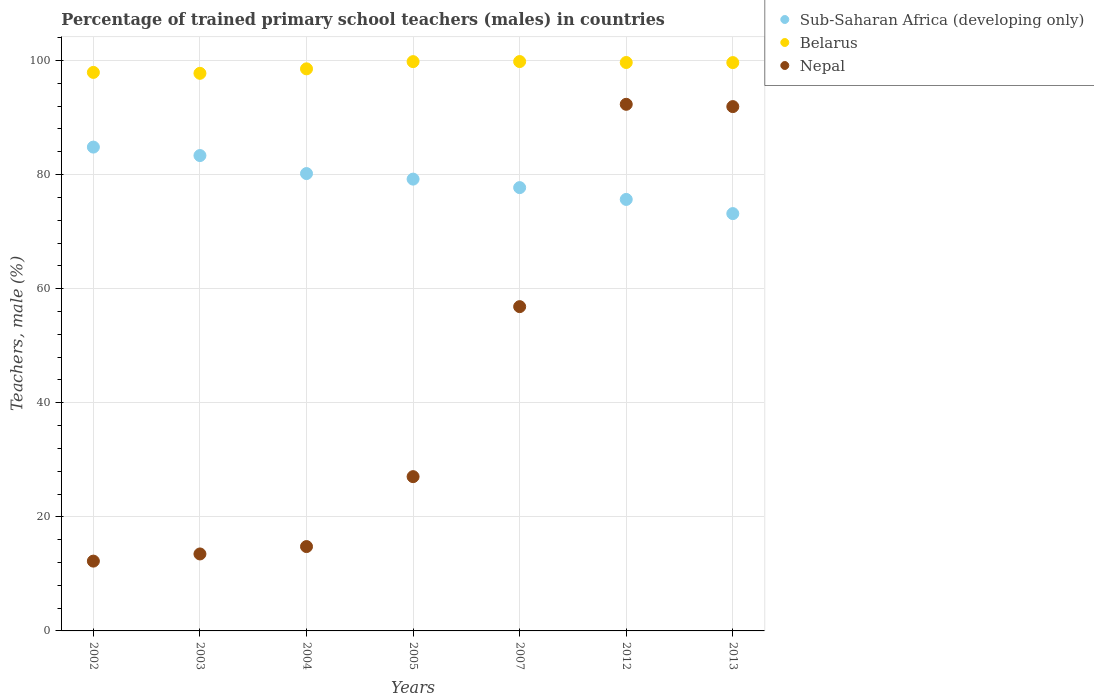What is the percentage of trained primary school teachers (males) in Sub-Saharan Africa (developing only) in 2013?
Make the answer very short. 73.15. Across all years, what is the maximum percentage of trained primary school teachers (males) in Nepal?
Keep it short and to the point. 92.31. Across all years, what is the minimum percentage of trained primary school teachers (males) in Sub-Saharan Africa (developing only)?
Offer a very short reply. 73.15. What is the total percentage of trained primary school teachers (males) in Nepal in the graph?
Provide a succinct answer. 308.63. What is the difference between the percentage of trained primary school teachers (males) in Belarus in 2003 and that in 2007?
Keep it short and to the point. -2.06. What is the difference between the percentage of trained primary school teachers (males) in Belarus in 2005 and the percentage of trained primary school teachers (males) in Sub-Saharan Africa (developing only) in 2007?
Provide a succinct answer. 22.08. What is the average percentage of trained primary school teachers (males) in Nepal per year?
Your answer should be very brief. 44.09. In the year 2002, what is the difference between the percentage of trained primary school teachers (males) in Sub-Saharan Africa (developing only) and percentage of trained primary school teachers (males) in Nepal?
Keep it short and to the point. 72.58. What is the ratio of the percentage of trained primary school teachers (males) in Belarus in 2002 to that in 2003?
Provide a succinct answer. 1. Is the percentage of trained primary school teachers (males) in Sub-Saharan Africa (developing only) in 2002 less than that in 2013?
Give a very brief answer. No. Is the difference between the percentage of trained primary school teachers (males) in Sub-Saharan Africa (developing only) in 2007 and 2013 greater than the difference between the percentage of trained primary school teachers (males) in Nepal in 2007 and 2013?
Keep it short and to the point. Yes. What is the difference between the highest and the second highest percentage of trained primary school teachers (males) in Nepal?
Your answer should be compact. 0.4. What is the difference between the highest and the lowest percentage of trained primary school teachers (males) in Nepal?
Offer a terse response. 80.08. In how many years, is the percentage of trained primary school teachers (males) in Belarus greater than the average percentage of trained primary school teachers (males) in Belarus taken over all years?
Ensure brevity in your answer.  4. Is the sum of the percentage of trained primary school teachers (males) in Sub-Saharan Africa (developing only) in 2004 and 2012 greater than the maximum percentage of trained primary school teachers (males) in Nepal across all years?
Offer a very short reply. Yes. Is it the case that in every year, the sum of the percentage of trained primary school teachers (males) in Nepal and percentage of trained primary school teachers (males) in Belarus  is greater than the percentage of trained primary school teachers (males) in Sub-Saharan Africa (developing only)?
Offer a very short reply. Yes. Is the percentage of trained primary school teachers (males) in Belarus strictly greater than the percentage of trained primary school teachers (males) in Nepal over the years?
Give a very brief answer. Yes. Is the percentage of trained primary school teachers (males) in Belarus strictly less than the percentage of trained primary school teachers (males) in Nepal over the years?
Your response must be concise. No. How many dotlines are there?
Ensure brevity in your answer.  3. How many years are there in the graph?
Provide a succinct answer. 7. Does the graph contain any zero values?
Provide a succinct answer. No. Does the graph contain grids?
Offer a very short reply. Yes. Where does the legend appear in the graph?
Give a very brief answer. Top right. What is the title of the graph?
Ensure brevity in your answer.  Percentage of trained primary school teachers (males) in countries. Does "Caribbean small states" appear as one of the legend labels in the graph?
Your answer should be very brief. No. What is the label or title of the X-axis?
Provide a succinct answer. Years. What is the label or title of the Y-axis?
Make the answer very short. Teachers, male (%). What is the Teachers, male (%) of Sub-Saharan Africa (developing only) in 2002?
Make the answer very short. 84.81. What is the Teachers, male (%) of Belarus in 2002?
Provide a succinct answer. 97.91. What is the Teachers, male (%) in Nepal in 2002?
Offer a very short reply. 12.24. What is the Teachers, male (%) in Sub-Saharan Africa (developing only) in 2003?
Ensure brevity in your answer.  83.33. What is the Teachers, male (%) of Belarus in 2003?
Offer a very short reply. 97.74. What is the Teachers, male (%) of Nepal in 2003?
Keep it short and to the point. 13.49. What is the Teachers, male (%) in Sub-Saharan Africa (developing only) in 2004?
Offer a very short reply. 80.17. What is the Teachers, male (%) in Belarus in 2004?
Provide a succinct answer. 98.53. What is the Teachers, male (%) of Nepal in 2004?
Offer a very short reply. 14.79. What is the Teachers, male (%) in Sub-Saharan Africa (developing only) in 2005?
Offer a very short reply. 79.2. What is the Teachers, male (%) of Belarus in 2005?
Your response must be concise. 99.8. What is the Teachers, male (%) of Nepal in 2005?
Ensure brevity in your answer.  27.04. What is the Teachers, male (%) in Sub-Saharan Africa (developing only) in 2007?
Offer a terse response. 77.71. What is the Teachers, male (%) in Belarus in 2007?
Provide a short and direct response. 99.81. What is the Teachers, male (%) of Nepal in 2007?
Your answer should be compact. 56.85. What is the Teachers, male (%) of Sub-Saharan Africa (developing only) in 2012?
Offer a very short reply. 75.64. What is the Teachers, male (%) in Belarus in 2012?
Give a very brief answer. 99.64. What is the Teachers, male (%) of Nepal in 2012?
Offer a very short reply. 92.31. What is the Teachers, male (%) in Sub-Saharan Africa (developing only) in 2013?
Provide a succinct answer. 73.15. What is the Teachers, male (%) of Belarus in 2013?
Provide a succinct answer. 99.63. What is the Teachers, male (%) in Nepal in 2013?
Make the answer very short. 91.91. Across all years, what is the maximum Teachers, male (%) in Sub-Saharan Africa (developing only)?
Ensure brevity in your answer.  84.81. Across all years, what is the maximum Teachers, male (%) of Belarus?
Your answer should be compact. 99.81. Across all years, what is the maximum Teachers, male (%) in Nepal?
Provide a succinct answer. 92.31. Across all years, what is the minimum Teachers, male (%) of Sub-Saharan Africa (developing only)?
Make the answer very short. 73.15. Across all years, what is the minimum Teachers, male (%) of Belarus?
Provide a short and direct response. 97.74. Across all years, what is the minimum Teachers, male (%) in Nepal?
Keep it short and to the point. 12.24. What is the total Teachers, male (%) of Sub-Saharan Africa (developing only) in the graph?
Make the answer very short. 554.02. What is the total Teachers, male (%) of Belarus in the graph?
Provide a short and direct response. 693.05. What is the total Teachers, male (%) of Nepal in the graph?
Your answer should be compact. 308.63. What is the difference between the Teachers, male (%) of Sub-Saharan Africa (developing only) in 2002 and that in 2003?
Make the answer very short. 1.48. What is the difference between the Teachers, male (%) of Belarus in 2002 and that in 2003?
Your answer should be very brief. 0.16. What is the difference between the Teachers, male (%) in Nepal in 2002 and that in 2003?
Offer a terse response. -1.26. What is the difference between the Teachers, male (%) in Sub-Saharan Africa (developing only) in 2002 and that in 2004?
Provide a short and direct response. 4.64. What is the difference between the Teachers, male (%) in Belarus in 2002 and that in 2004?
Provide a succinct answer. -0.62. What is the difference between the Teachers, male (%) in Nepal in 2002 and that in 2004?
Ensure brevity in your answer.  -2.55. What is the difference between the Teachers, male (%) in Sub-Saharan Africa (developing only) in 2002 and that in 2005?
Your answer should be compact. 5.61. What is the difference between the Teachers, male (%) of Belarus in 2002 and that in 2005?
Make the answer very short. -1.89. What is the difference between the Teachers, male (%) of Nepal in 2002 and that in 2005?
Provide a short and direct response. -14.81. What is the difference between the Teachers, male (%) of Sub-Saharan Africa (developing only) in 2002 and that in 2007?
Give a very brief answer. 7.1. What is the difference between the Teachers, male (%) in Belarus in 2002 and that in 2007?
Keep it short and to the point. -1.9. What is the difference between the Teachers, male (%) of Nepal in 2002 and that in 2007?
Your response must be concise. -44.61. What is the difference between the Teachers, male (%) of Sub-Saharan Africa (developing only) in 2002 and that in 2012?
Offer a terse response. 9.17. What is the difference between the Teachers, male (%) of Belarus in 2002 and that in 2012?
Ensure brevity in your answer.  -1.74. What is the difference between the Teachers, male (%) of Nepal in 2002 and that in 2012?
Your response must be concise. -80.08. What is the difference between the Teachers, male (%) of Sub-Saharan Africa (developing only) in 2002 and that in 2013?
Your answer should be compact. 11.66. What is the difference between the Teachers, male (%) in Belarus in 2002 and that in 2013?
Provide a succinct answer. -1.72. What is the difference between the Teachers, male (%) of Nepal in 2002 and that in 2013?
Your response must be concise. -79.68. What is the difference between the Teachers, male (%) of Sub-Saharan Africa (developing only) in 2003 and that in 2004?
Give a very brief answer. 3.16. What is the difference between the Teachers, male (%) of Belarus in 2003 and that in 2004?
Offer a very short reply. -0.79. What is the difference between the Teachers, male (%) of Nepal in 2003 and that in 2004?
Ensure brevity in your answer.  -1.29. What is the difference between the Teachers, male (%) in Sub-Saharan Africa (developing only) in 2003 and that in 2005?
Give a very brief answer. 4.13. What is the difference between the Teachers, male (%) in Belarus in 2003 and that in 2005?
Your answer should be very brief. -2.05. What is the difference between the Teachers, male (%) of Nepal in 2003 and that in 2005?
Offer a very short reply. -13.55. What is the difference between the Teachers, male (%) of Sub-Saharan Africa (developing only) in 2003 and that in 2007?
Offer a terse response. 5.62. What is the difference between the Teachers, male (%) of Belarus in 2003 and that in 2007?
Provide a short and direct response. -2.06. What is the difference between the Teachers, male (%) in Nepal in 2003 and that in 2007?
Your answer should be compact. -43.35. What is the difference between the Teachers, male (%) of Sub-Saharan Africa (developing only) in 2003 and that in 2012?
Offer a very short reply. 7.69. What is the difference between the Teachers, male (%) in Belarus in 2003 and that in 2012?
Offer a terse response. -1.9. What is the difference between the Teachers, male (%) in Nepal in 2003 and that in 2012?
Make the answer very short. -78.82. What is the difference between the Teachers, male (%) in Sub-Saharan Africa (developing only) in 2003 and that in 2013?
Offer a very short reply. 10.18. What is the difference between the Teachers, male (%) in Belarus in 2003 and that in 2013?
Give a very brief answer. -1.88. What is the difference between the Teachers, male (%) of Nepal in 2003 and that in 2013?
Your answer should be very brief. -78.42. What is the difference between the Teachers, male (%) in Sub-Saharan Africa (developing only) in 2004 and that in 2005?
Give a very brief answer. 0.97. What is the difference between the Teachers, male (%) of Belarus in 2004 and that in 2005?
Ensure brevity in your answer.  -1.26. What is the difference between the Teachers, male (%) of Nepal in 2004 and that in 2005?
Give a very brief answer. -12.26. What is the difference between the Teachers, male (%) of Sub-Saharan Africa (developing only) in 2004 and that in 2007?
Your answer should be very brief. 2.46. What is the difference between the Teachers, male (%) of Belarus in 2004 and that in 2007?
Offer a terse response. -1.28. What is the difference between the Teachers, male (%) of Nepal in 2004 and that in 2007?
Provide a short and direct response. -42.06. What is the difference between the Teachers, male (%) in Sub-Saharan Africa (developing only) in 2004 and that in 2012?
Provide a short and direct response. 4.53. What is the difference between the Teachers, male (%) of Belarus in 2004 and that in 2012?
Offer a very short reply. -1.11. What is the difference between the Teachers, male (%) in Nepal in 2004 and that in 2012?
Your answer should be compact. -77.53. What is the difference between the Teachers, male (%) in Sub-Saharan Africa (developing only) in 2004 and that in 2013?
Offer a very short reply. 7.02. What is the difference between the Teachers, male (%) in Belarus in 2004 and that in 2013?
Your answer should be very brief. -1.1. What is the difference between the Teachers, male (%) of Nepal in 2004 and that in 2013?
Provide a short and direct response. -77.13. What is the difference between the Teachers, male (%) in Sub-Saharan Africa (developing only) in 2005 and that in 2007?
Provide a succinct answer. 1.49. What is the difference between the Teachers, male (%) of Belarus in 2005 and that in 2007?
Give a very brief answer. -0.01. What is the difference between the Teachers, male (%) in Nepal in 2005 and that in 2007?
Ensure brevity in your answer.  -29.8. What is the difference between the Teachers, male (%) in Sub-Saharan Africa (developing only) in 2005 and that in 2012?
Your answer should be very brief. 3.56. What is the difference between the Teachers, male (%) in Belarus in 2005 and that in 2012?
Offer a terse response. 0.15. What is the difference between the Teachers, male (%) of Nepal in 2005 and that in 2012?
Give a very brief answer. -65.27. What is the difference between the Teachers, male (%) of Sub-Saharan Africa (developing only) in 2005 and that in 2013?
Provide a short and direct response. 6.05. What is the difference between the Teachers, male (%) of Belarus in 2005 and that in 2013?
Keep it short and to the point. 0.17. What is the difference between the Teachers, male (%) in Nepal in 2005 and that in 2013?
Your answer should be very brief. -64.87. What is the difference between the Teachers, male (%) of Sub-Saharan Africa (developing only) in 2007 and that in 2012?
Provide a short and direct response. 2.07. What is the difference between the Teachers, male (%) in Belarus in 2007 and that in 2012?
Make the answer very short. 0.17. What is the difference between the Teachers, male (%) of Nepal in 2007 and that in 2012?
Ensure brevity in your answer.  -35.47. What is the difference between the Teachers, male (%) in Sub-Saharan Africa (developing only) in 2007 and that in 2013?
Your answer should be very brief. 4.56. What is the difference between the Teachers, male (%) of Belarus in 2007 and that in 2013?
Offer a terse response. 0.18. What is the difference between the Teachers, male (%) in Nepal in 2007 and that in 2013?
Give a very brief answer. -35.07. What is the difference between the Teachers, male (%) in Sub-Saharan Africa (developing only) in 2012 and that in 2013?
Provide a succinct answer. 2.49. What is the difference between the Teachers, male (%) of Belarus in 2012 and that in 2013?
Your answer should be compact. 0.02. What is the difference between the Teachers, male (%) in Nepal in 2012 and that in 2013?
Ensure brevity in your answer.  0.4. What is the difference between the Teachers, male (%) in Sub-Saharan Africa (developing only) in 2002 and the Teachers, male (%) in Belarus in 2003?
Offer a very short reply. -12.93. What is the difference between the Teachers, male (%) of Sub-Saharan Africa (developing only) in 2002 and the Teachers, male (%) of Nepal in 2003?
Offer a terse response. 71.32. What is the difference between the Teachers, male (%) in Belarus in 2002 and the Teachers, male (%) in Nepal in 2003?
Offer a very short reply. 84.41. What is the difference between the Teachers, male (%) of Sub-Saharan Africa (developing only) in 2002 and the Teachers, male (%) of Belarus in 2004?
Keep it short and to the point. -13.72. What is the difference between the Teachers, male (%) of Sub-Saharan Africa (developing only) in 2002 and the Teachers, male (%) of Nepal in 2004?
Your answer should be compact. 70.03. What is the difference between the Teachers, male (%) in Belarus in 2002 and the Teachers, male (%) in Nepal in 2004?
Ensure brevity in your answer.  83.12. What is the difference between the Teachers, male (%) in Sub-Saharan Africa (developing only) in 2002 and the Teachers, male (%) in Belarus in 2005?
Provide a short and direct response. -14.98. What is the difference between the Teachers, male (%) in Sub-Saharan Africa (developing only) in 2002 and the Teachers, male (%) in Nepal in 2005?
Your answer should be compact. 57.77. What is the difference between the Teachers, male (%) in Belarus in 2002 and the Teachers, male (%) in Nepal in 2005?
Give a very brief answer. 70.86. What is the difference between the Teachers, male (%) in Sub-Saharan Africa (developing only) in 2002 and the Teachers, male (%) in Belarus in 2007?
Your response must be concise. -15. What is the difference between the Teachers, male (%) in Sub-Saharan Africa (developing only) in 2002 and the Teachers, male (%) in Nepal in 2007?
Provide a succinct answer. 27.97. What is the difference between the Teachers, male (%) of Belarus in 2002 and the Teachers, male (%) of Nepal in 2007?
Keep it short and to the point. 41.06. What is the difference between the Teachers, male (%) of Sub-Saharan Africa (developing only) in 2002 and the Teachers, male (%) of Belarus in 2012?
Ensure brevity in your answer.  -14.83. What is the difference between the Teachers, male (%) of Sub-Saharan Africa (developing only) in 2002 and the Teachers, male (%) of Nepal in 2012?
Provide a short and direct response. -7.5. What is the difference between the Teachers, male (%) of Belarus in 2002 and the Teachers, male (%) of Nepal in 2012?
Offer a very short reply. 5.59. What is the difference between the Teachers, male (%) in Sub-Saharan Africa (developing only) in 2002 and the Teachers, male (%) in Belarus in 2013?
Your answer should be compact. -14.81. What is the difference between the Teachers, male (%) in Sub-Saharan Africa (developing only) in 2002 and the Teachers, male (%) in Nepal in 2013?
Make the answer very short. -7.1. What is the difference between the Teachers, male (%) in Belarus in 2002 and the Teachers, male (%) in Nepal in 2013?
Provide a short and direct response. 5.99. What is the difference between the Teachers, male (%) of Sub-Saharan Africa (developing only) in 2003 and the Teachers, male (%) of Belarus in 2004?
Your response must be concise. -15.2. What is the difference between the Teachers, male (%) of Sub-Saharan Africa (developing only) in 2003 and the Teachers, male (%) of Nepal in 2004?
Make the answer very short. 68.54. What is the difference between the Teachers, male (%) of Belarus in 2003 and the Teachers, male (%) of Nepal in 2004?
Make the answer very short. 82.96. What is the difference between the Teachers, male (%) in Sub-Saharan Africa (developing only) in 2003 and the Teachers, male (%) in Belarus in 2005?
Provide a short and direct response. -16.46. What is the difference between the Teachers, male (%) in Sub-Saharan Africa (developing only) in 2003 and the Teachers, male (%) in Nepal in 2005?
Your answer should be compact. 56.29. What is the difference between the Teachers, male (%) of Belarus in 2003 and the Teachers, male (%) of Nepal in 2005?
Ensure brevity in your answer.  70.7. What is the difference between the Teachers, male (%) in Sub-Saharan Africa (developing only) in 2003 and the Teachers, male (%) in Belarus in 2007?
Give a very brief answer. -16.48. What is the difference between the Teachers, male (%) of Sub-Saharan Africa (developing only) in 2003 and the Teachers, male (%) of Nepal in 2007?
Provide a succinct answer. 26.49. What is the difference between the Teachers, male (%) of Belarus in 2003 and the Teachers, male (%) of Nepal in 2007?
Your response must be concise. 40.9. What is the difference between the Teachers, male (%) of Sub-Saharan Africa (developing only) in 2003 and the Teachers, male (%) of Belarus in 2012?
Your response must be concise. -16.31. What is the difference between the Teachers, male (%) in Sub-Saharan Africa (developing only) in 2003 and the Teachers, male (%) in Nepal in 2012?
Provide a short and direct response. -8.98. What is the difference between the Teachers, male (%) of Belarus in 2003 and the Teachers, male (%) of Nepal in 2012?
Your answer should be very brief. 5.43. What is the difference between the Teachers, male (%) in Sub-Saharan Africa (developing only) in 2003 and the Teachers, male (%) in Belarus in 2013?
Your response must be concise. -16.3. What is the difference between the Teachers, male (%) in Sub-Saharan Africa (developing only) in 2003 and the Teachers, male (%) in Nepal in 2013?
Your answer should be compact. -8.58. What is the difference between the Teachers, male (%) in Belarus in 2003 and the Teachers, male (%) in Nepal in 2013?
Your answer should be very brief. 5.83. What is the difference between the Teachers, male (%) in Sub-Saharan Africa (developing only) in 2004 and the Teachers, male (%) in Belarus in 2005?
Offer a terse response. -19.62. What is the difference between the Teachers, male (%) of Sub-Saharan Africa (developing only) in 2004 and the Teachers, male (%) of Nepal in 2005?
Provide a succinct answer. 53.13. What is the difference between the Teachers, male (%) in Belarus in 2004 and the Teachers, male (%) in Nepal in 2005?
Your answer should be compact. 71.49. What is the difference between the Teachers, male (%) of Sub-Saharan Africa (developing only) in 2004 and the Teachers, male (%) of Belarus in 2007?
Offer a terse response. -19.63. What is the difference between the Teachers, male (%) of Sub-Saharan Africa (developing only) in 2004 and the Teachers, male (%) of Nepal in 2007?
Your response must be concise. 23.33. What is the difference between the Teachers, male (%) of Belarus in 2004 and the Teachers, male (%) of Nepal in 2007?
Offer a very short reply. 41.69. What is the difference between the Teachers, male (%) in Sub-Saharan Africa (developing only) in 2004 and the Teachers, male (%) in Belarus in 2012?
Give a very brief answer. -19.47. What is the difference between the Teachers, male (%) in Sub-Saharan Africa (developing only) in 2004 and the Teachers, male (%) in Nepal in 2012?
Your answer should be compact. -12.14. What is the difference between the Teachers, male (%) in Belarus in 2004 and the Teachers, male (%) in Nepal in 2012?
Keep it short and to the point. 6.22. What is the difference between the Teachers, male (%) in Sub-Saharan Africa (developing only) in 2004 and the Teachers, male (%) in Belarus in 2013?
Offer a very short reply. -19.45. What is the difference between the Teachers, male (%) of Sub-Saharan Africa (developing only) in 2004 and the Teachers, male (%) of Nepal in 2013?
Provide a succinct answer. -11.74. What is the difference between the Teachers, male (%) in Belarus in 2004 and the Teachers, male (%) in Nepal in 2013?
Your answer should be compact. 6.62. What is the difference between the Teachers, male (%) in Sub-Saharan Africa (developing only) in 2005 and the Teachers, male (%) in Belarus in 2007?
Offer a very short reply. -20.61. What is the difference between the Teachers, male (%) in Sub-Saharan Africa (developing only) in 2005 and the Teachers, male (%) in Nepal in 2007?
Your response must be concise. 22.35. What is the difference between the Teachers, male (%) in Belarus in 2005 and the Teachers, male (%) in Nepal in 2007?
Give a very brief answer. 42.95. What is the difference between the Teachers, male (%) of Sub-Saharan Africa (developing only) in 2005 and the Teachers, male (%) of Belarus in 2012?
Ensure brevity in your answer.  -20.44. What is the difference between the Teachers, male (%) of Sub-Saharan Africa (developing only) in 2005 and the Teachers, male (%) of Nepal in 2012?
Provide a succinct answer. -13.11. What is the difference between the Teachers, male (%) of Belarus in 2005 and the Teachers, male (%) of Nepal in 2012?
Provide a short and direct response. 7.48. What is the difference between the Teachers, male (%) in Sub-Saharan Africa (developing only) in 2005 and the Teachers, male (%) in Belarus in 2013?
Provide a succinct answer. -20.43. What is the difference between the Teachers, male (%) in Sub-Saharan Africa (developing only) in 2005 and the Teachers, male (%) in Nepal in 2013?
Your answer should be compact. -12.71. What is the difference between the Teachers, male (%) in Belarus in 2005 and the Teachers, male (%) in Nepal in 2013?
Give a very brief answer. 7.88. What is the difference between the Teachers, male (%) of Sub-Saharan Africa (developing only) in 2007 and the Teachers, male (%) of Belarus in 2012?
Your response must be concise. -21.93. What is the difference between the Teachers, male (%) in Sub-Saharan Africa (developing only) in 2007 and the Teachers, male (%) in Nepal in 2012?
Give a very brief answer. -14.6. What is the difference between the Teachers, male (%) of Belarus in 2007 and the Teachers, male (%) of Nepal in 2012?
Your answer should be very brief. 7.49. What is the difference between the Teachers, male (%) of Sub-Saharan Africa (developing only) in 2007 and the Teachers, male (%) of Belarus in 2013?
Your answer should be very brief. -21.92. What is the difference between the Teachers, male (%) in Sub-Saharan Africa (developing only) in 2007 and the Teachers, male (%) in Nepal in 2013?
Provide a short and direct response. -14.2. What is the difference between the Teachers, male (%) of Belarus in 2007 and the Teachers, male (%) of Nepal in 2013?
Your answer should be very brief. 7.9. What is the difference between the Teachers, male (%) in Sub-Saharan Africa (developing only) in 2012 and the Teachers, male (%) in Belarus in 2013?
Offer a terse response. -23.99. What is the difference between the Teachers, male (%) of Sub-Saharan Africa (developing only) in 2012 and the Teachers, male (%) of Nepal in 2013?
Offer a terse response. -16.27. What is the difference between the Teachers, male (%) of Belarus in 2012 and the Teachers, male (%) of Nepal in 2013?
Keep it short and to the point. 7.73. What is the average Teachers, male (%) in Sub-Saharan Africa (developing only) per year?
Your answer should be very brief. 79.15. What is the average Teachers, male (%) of Belarus per year?
Your response must be concise. 99.01. What is the average Teachers, male (%) of Nepal per year?
Your answer should be compact. 44.09. In the year 2002, what is the difference between the Teachers, male (%) of Sub-Saharan Africa (developing only) and Teachers, male (%) of Belarus?
Make the answer very short. -13.09. In the year 2002, what is the difference between the Teachers, male (%) in Sub-Saharan Africa (developing only) and Teachers, male (%) in Nepal?
Offer a very short reply. 72.58. In the year 2002, what is the difference between the Teachers, male (%) of Belarus and Teachers, male (%) of Nepal?
Give a very brief answer. 85.67. In the year 2003, what is the difference between the Teachers, male (%) in Sub-Saharan Africa (developing only) and Teachers, male (%) in Belarus?
Your answer should be compact. -14.41. In the year 2003, what is the difference between the Teachers, male (%) in Sub-Saharan Africa (developing only) and Teachers, male (%) in Nepal?
Offer a terse response. 69.84. In the year 2003, what is the difference between the Teachers, male (%) of Belarus and Teachers, male (%) of Nepal?
Give a very brief answer. 84.25. In the year 2004, what is the difference between the Teachers, male (%) in Sub-Saharan Africa (developing only) and Teachers, male (%) in Belarus?
Your answer should be very brief. -18.36. In the year 2004, what is the difference between the Teachers, male (%) of Sub-Saharan Africa (developing only) and Teachers, male (%) of Nepal?
Your answer should be very brief. 65.39. In the year 2004, what is the difference between the Teachers, male (%) in Belarus and Teachers, male (%) in Nepal?
Your answer should be compact. 83.74. In the year 2005, what is the difference between the Teachers, male (%) in Sub-Saharan Africa (developing only) and Teachers, male (%) in Belarus?
Give a very brief answer. -20.6. In the year 2005, what is the difference between the Teachers, male (%) of Sub-Saharan Africa (developing only) and Teachers, male (%) of Nepal?
Provide a short and direct response. 52.16. In the year 2005, what is the difference between the Teachers, male (%) in Belarus and Teachers, male (%) in Nepal?
Offer a terse response. 72.75. In the year 2007, what is the difference between the Teachers, male (%) of Sub-Saharan Africa (developing only) and Teachers, male (%) of Belarus?
Ensure brevity in your answer.  -22.1. In the year 2007, what is the difference between the Teachers, male (%) of Sub-Saharan Africa (developing only) and Teachers, male (%) of Nepal?
Ensure brevity in your answer.  20.87. In the year 2007, what is the difference between the Teachers, male (%) in Belarus and Teachers, male (%) in Nepal?
Your response must be concise. 42.96. In the year 2012, what is the difference between the Teachers, male (%) in Sub-Saharan Africa (developing only) and Teachers, male (%) in Belarus?
Your answer should be very brief. -24. In the year 2012, what is the difference between the Teachers, male (%) of Sub-Saharan Africa (developing only) and Teachers, male (%) of Nepal?
Make the answer very short. -16.67. In the year 2012, what is the difference between the Teachers, male (%) in Belarus and Teachers, male (%) in Nepal?
Ensure brevity in your answer.  7.33. In the year 2013, what is the difference between the Teachers, male (%) in Sub-Saharan Africa (developing only) and Teachers, male (%) in Belarus?
Ensure brevity in your answer.  -26.47. In the year 2013, what is the difference between the Teachers, male (%) of Sub-Saharan Africa (developing only) and Teachers, male (%) of Nepal?
Keep it short and to the point. -18.76. In the year 2013, what is the difference between the Teachers, male (%) of Belarus and Teachers, male (%) of Nepal?
Provide a succinct answer. 7.71. What is the ratio of the Teachers, male (%) of Sub-Saharan Africa (developing only) in 2002 to that in 2003?
Make the answer very short. 1.02. What is the ratio of the Teachers, male (%) of Nepal in 2002 to that in 2003?
Offer a terse response. 0.91. What is the ratio of the Teachers, male (%) of Sub-Saharan Africa (developing only) in 2002 to that in 2004?
Your answer should be compact. 1.06. What is the ratio of the Teachers, male (%) in Belarus in 2002 to that in 2004?
Keep it short and to the point. 0.99. What is the ratio of the Teachers, male (%) of Nepal in 2002 to that in 2004?
Your answer should be compact. 0.83. What is the ratio of the Teachers, male (%) in Sub-Saharan Africa (developing only) in 2002 to that in 2005?
Provide a short and direct response. 1.07. What is the ratio of the Teachers, male (%) in Belarus in 2002 to that in 2005?
Give a very brief answer. 0.98. What is the ratio of the Teachers, male (%) of Nepal in 2002 to that in 2005?
Your response must be concise. 0.45. What is the ratio of the Teachers, male (%) in Sub-Saharan Africa (developing only) in 2002 to that in 2007?
Provide a succinct answer. 1.09. What is the ratio of the Teachers, male (%) of Belarus in 2002 to that in 2007?
Provide a short and direct response. 0.98. What is the ratio of the Teachers, male (%) of Nepal in 2002 to that in 2007?
Ensure brevity in your answer.  0.22. What is the ratio of the Teachers, male (%) in Sub-Saharan Africa (developing only) in 2002 to that in 2012?
Your answer should be very brief. 1.12. What is the ratio of the Teachers, male (%) in Belarus in 2002 to that in 2012?
Provide a short and direct response. 0.98. What is the ratio of the Teachers, male (%) of Nepal in 2002 to that in 2012?
Keep it short and to the point. 0.13. What is the ratio of the Teachers, male (%) in Sub-Saharan Africa (developing only) in 2002 to that in 2013?
Offer a very short reply. 1.16. What is the ratio of the Teachers, male (%) of Belarus in 2002 to that in 2013?
Make the answer very short. 0.98. What is the ratio of the Teachers, male (%) of Nepal in 2002 to that in 2013?
Offer a terse response. 0.13. What is the ratio of the Teachers, male (%) in Sub-Saharan Africa (developing only) in 2003 to that in 2004?
Ensure brevity in your answer.  1.04. What is the ratio of the Teachers, male (%) of Belarus in 2003 to that in 2004?
Make the answer very short. 0.99. What is the ratio of the Teachers, male (%) in Nepal in 2003 to that in 2004?
Your answer should be compact. 0.91. What is the ratio of the Teachers, male (%) of Sub-Saharan Africa (developing only) in 2003 to that in 2005?
Your answer should be compact. 1.05. What is the ratio of the Teachers, male (%) of Belarus in 2003 to that in 2005?
Make the answer very short. 0.98. What is the ratio of the Teachers, male (%) in Nepal in 2003 to that in 2005?
Your answer should be compact. 0.5. What is the ratio of the Teachers, male (%) in Sub-Saharan Africa (developing only) in 2003 to that in 2007?
Provide a short and direct response. 1.07. What is the ratio of the Teachers, male (%) of Belarus in 2003 to that in 2007?
Your answer should be very brief. 0.98. What is the ratio of the Teachers, male (%) in Nepal in 2003 to that in 2007?
Give a very brief answer. 0.24. What is the ratio of the Teachers, male (%) of Sub-Saharan Africa (developing only) in 2003 to that in 2012?
Your response must be concise. 1.1. What is the ratio of the Teachers, male (%) of Nepal in 2003 to that in 2012?
Provide a succinct answer. 0.15. What is the ratio of the Teachers, male (%) of Sub-Saharan Africa (developing only) in 2003 to that in 2013?
Make the answer very short. 1.14. What is the ratio of the Teachers, male (%) in Belarus in 2003 to that in 2013?
Keep it short and to the point. 0.98. What is the ratio of the Teachers, male (%) in Nepal in 2003 to that in 2013?
Offer a terse response. 0.15. What is the ratio of the Teachers, male (%) of Sub-Saharan Africa (developing only) in 2004 to that in 2005?
Make the answer very short. 1.01. What is the ratio of the Teachers, male (%) in Belarus in 2004 to that in 2005?
Your response must be concise. 0.99. What is the ratio of the Teachers, male (%) in Nepal in 2004 to that in 2005?
Offer a very short reply. 0.55. What is the ratio of the Teachers, male (%) in Sub-Saharan Africa (developing only) in 2004 to that in 2007?
Your response must be concise. 1.03. What is the ratio of the Teachers, male (%) in Belarus in 2004 to that in 2007?
Your answer should be compact. 0.99. What is the ratio of the Teachers, male (%) in Nepal in 2004 to that in 2007?
Your answer should be very brief. 0.26. What is the ratio of the Teachers, male (%) of Sub-Saharan Africa (developing only) in 2004 to that in 2012?
Offer a very short reply. 1.06. What is the ratio of the Teachers, male (%) in Belarus in 2004 to that in 2012?
Provide a succinct answer. 0.99. What is the ratio of the Teachers, male (%) in Nepal in 2004 to that in 2012?
Give a very brief answer. 0.16. What is the ratio of the Teachers, male (%) of Sub-Saharan Africa (developing only) in 2004 to that in 2013?
Keep it short and to the point. 1.1. What is the ratio of the Teachers, male (%) of Nepal in 2004 to that in 2013?
Provide a succinct answer. 0.16. What is the ratio of the Teachers, male (%) of Sub-Saharan Africa (developing only) in 2005 to that in 2007?
Provide a short and direct response. 1.02. What is the ratio of the Teachers, male (%) in Belarus in 2005 to that in 2007?
Provide a short and direct response. 1. What is the ratio of the Teachers, male (%) in Nepal in 2005 to that in 2007?
Provide a short and direct response. 0.48. What is the ratio of the Teachers, male (%) in Sub-Saharan Africa (developing only) in 2005 to that in 2012?
Provide a succinct answer. 1.05. What is the ratio of the Teachers, male (%) in Belarus in 2005 to that in 2012?
Your answer should be very brief. 1. What is the ratio of the Teachers, male (%) of Nepal in 2005 to that in 2012?
Your answer should be very brief. 0.29. What is the ratio of the Teachers, male (%) in Sub-Saharan Africa (developing only) in 2005 to that in 2013?
Give a very brief answer. 1.08. What is the ratio of the Teachers, male (%) of Nepal in 2005 to that in 2013?
Offer a very short reply. 0.29. What is the ratio of the Teachers, male (%) of Sub-Saharan Africa (developing only) in 2007 to that in 2012?
Offer a terse response. 1.03. What is the ratio of the Teachers, male (%) in Belarus in 2007 to that in 2012?
Ensure brevity in your answer.  1. What is the ratio of the Teachers, male (%) of Nepal in 2007 to that in 2012?
Provide a succinct answer. 0.62. What is the ratio of the Teachers, male (%) of Sub-Saharan Africa (developing only) in 2007 to that in 2013?
Keep it short and to the point. 1.06. What is the ratio of the Teachers, male (%) of Belarus in 2007 to that in 2013?
Your response must be concise. 1. What is the ratio of the Teachers, male (%) of Nepal in 2007 to that in 2013?
Your answer should be compact. 0.62. What is the ratio of the Teachers, male (%) of Sub-Saharan Africa (developing only) in 2012 to that in 2013?
Ensure brevity in your answer.  1.03. What is the ratio of the Teachers, male (%) in Nepal in 2012 to that in 2013?
Ensure brevity in your answer.  1. What is the difference between the highest and the second highest Teachers, male (%) of Sub-Saharan Africa (developing only)?
Provide a succinct answer. 1.48. What is the difference between the highest and the second highest Teachers, male (%) of Belarus?
Keep it short and to the point. 0.01. What is the difference between the highest and the second highest Teachers, male (%) of Nepal?
Give a very brief answer. 0.4. What is the difference between the highest and the lowest Teachers, male (%) in Sub-Saharan Africa (developing only)?
Your response must be concise. 11.66. What is the difference between the highest and the lowest Teachers, male (%) of Belarus?
Your answer should be compact. 2.06. What is the difference between the highest and the lowest Teachers, male (%) of Nepal?
Provide a short and direct response. 80.08. 